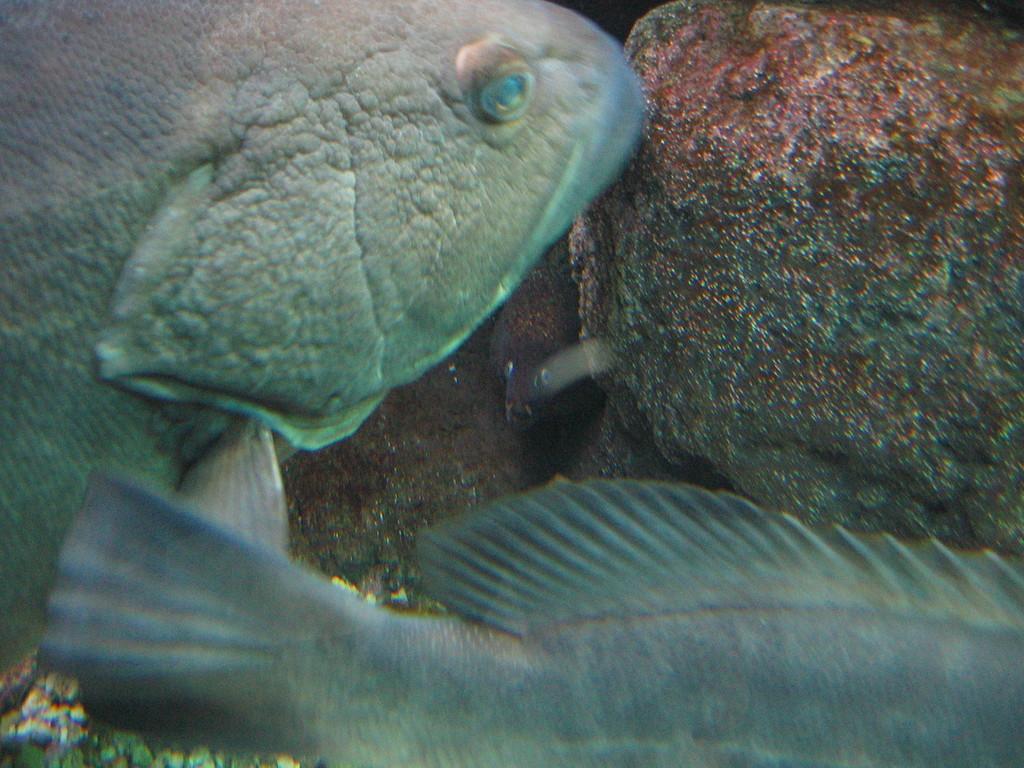How would you summarize this image in a sentence or two? This seems like a water body and here we can see fishes and rocks. 